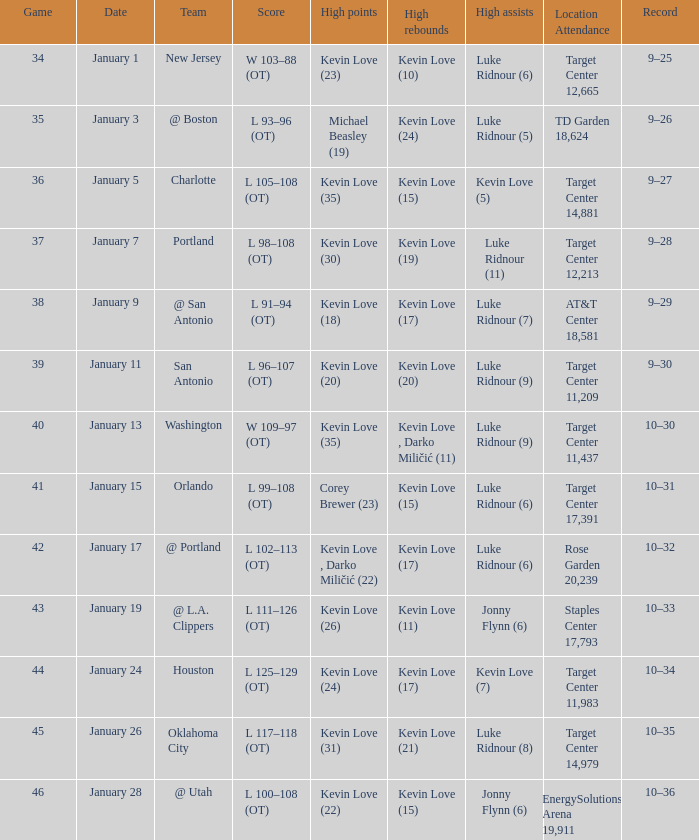What is the date for the game with team orlando? January 15. 